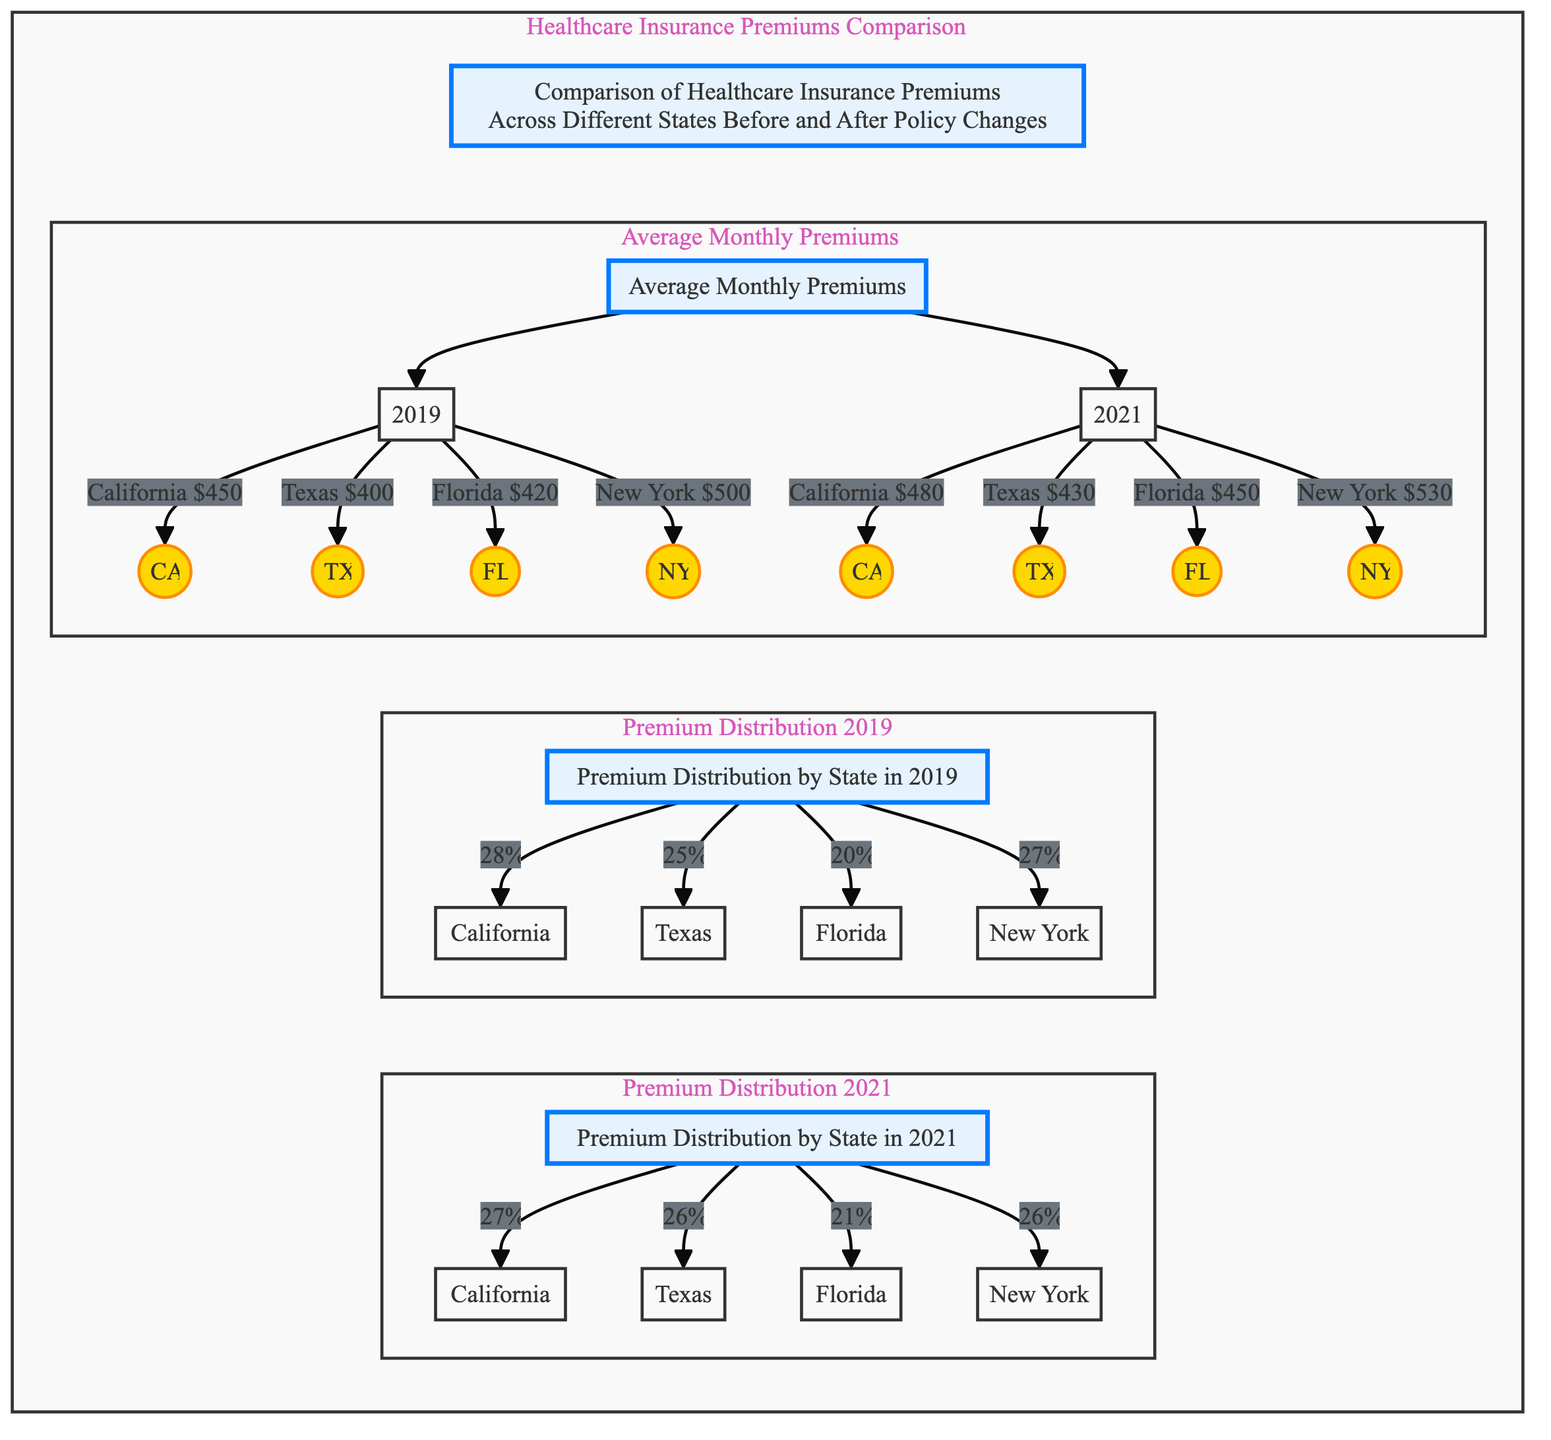What was the average monthly premium for California in 2019? In the diagram, we find California (CA) listed under the average monthly premiums for 2019, which shows $450.
Answer: $450 What percentage of the premium distribution did Texas represent in 2021? Looking at the premium distribution in 2021, Texas (TX) is noted to represent 26%.
Answer: 26% Which state had the highest average monthly premium in 2021? In 2021, the average monthly premium for New York (NY) is shown to be $530, which is higher than other states.
Answer: $530 What is the change in average monthly premium for Florida from 2019 to 2021? Florida's average premium in 2019 was $420 and in 2021 it increased to $450. Thus, the change can be calculated as $450 - $420, which is $30.
Answer: $30 Which state had a decrease in its premium percentage from 2019 to 2021? By comparing the distributions, California decreased from 28% in 2019 to 27% in 2021, highlighting a decline.
Answer: California How many states are represented in the average monthly premiums comparison? The diagram shows average monthly premiums for four states: California, Texas, Florida, and New York, making a total of four states.
Answer: 4 